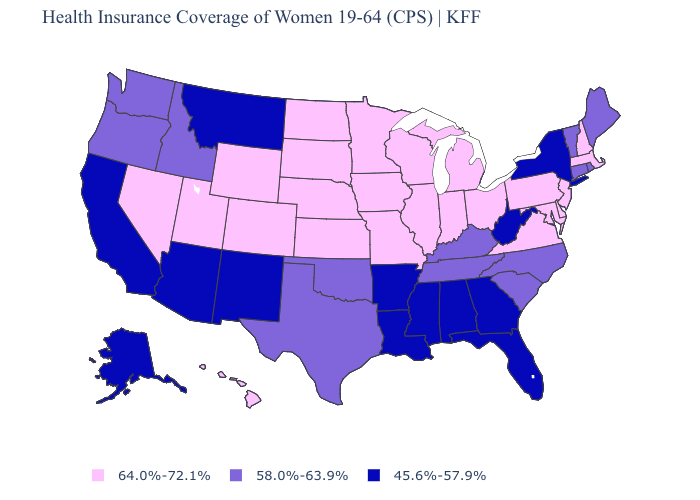What is the value of Tennessee?
Be succinct. 58.0%-63.9%. What is the value of Arkansas?
Write a very short answer. 45.6%-57.9%. Which states have the highest value in the USA?
Keep it brief. Colorado, Delaware, Hawaii, Illinois, Indiana, Iowa, Kansas, Maryland, Massachusetts, Michigan, Minnesota, Missouri, Nebraska, Nevada, New Hampshire, New Jersey, North Dakota, Ohio, Pennsylvania, South Dakota, Utah, Virginia, Wisconsin, Wyoming. Name the states that have a value in the range 64.0%-72.1%?
Be succinct. Colorado, Delaware, Hawaii, Illinois, Indiana, Iowa, Kansas, Maryland, Massachusetts, Michigan, Minnesota, Missouri, Nebraska, Nevada, New Hampshire, New Jersey, North Dakota, Ohio, Pennsylvania, South Dakota, Utah, Virginia, Wisconsin, Wyoming. How many symbols are there in the legend?
Be succinct. 3. Does North Dakota have a higher value than Illinois?
Concise answer only. No. What is the lowest value in the USA?
Concise answer only. 45.6%-57.9%. Among the states that border Maryland , does West Virginia have the lowest value?
Give a very brief answer. Yes. Is the legend a continuous bar?
Short answer required. No. Name the states that have a value in the range 64.0%-72.1%?
Short answer required. Colorado, Delaware, Hawaii, Illinois, Indiana, Iowa, Kansas, Maryland, Massachusetts, Michigan, Minnesota, Missouri, Nebraska, Nevada, New Hampshire, New Jersey, North Dakota, Ohio, Pennsylvania, South Dakota, Utah, Virginia, Wisconsin, Wyoming. Name the states that have a value in the range 45.6%-57.9%?
Answer briefly. Alabama, Alaska, Arizona, Arkansas, California, Florida, Georgia, Louisiana, Mississippi, Montana, New Mexico, New York, West Virginia. What is the value of Nevada?
Give a very brief answer. 64.0%-72.1%. What is the highest value in the USA?
Write a very short answer. 64.0%-72.1%. What is the highest value in states that border Indiana?
Concise answer only. 64.0%-72.1%. 